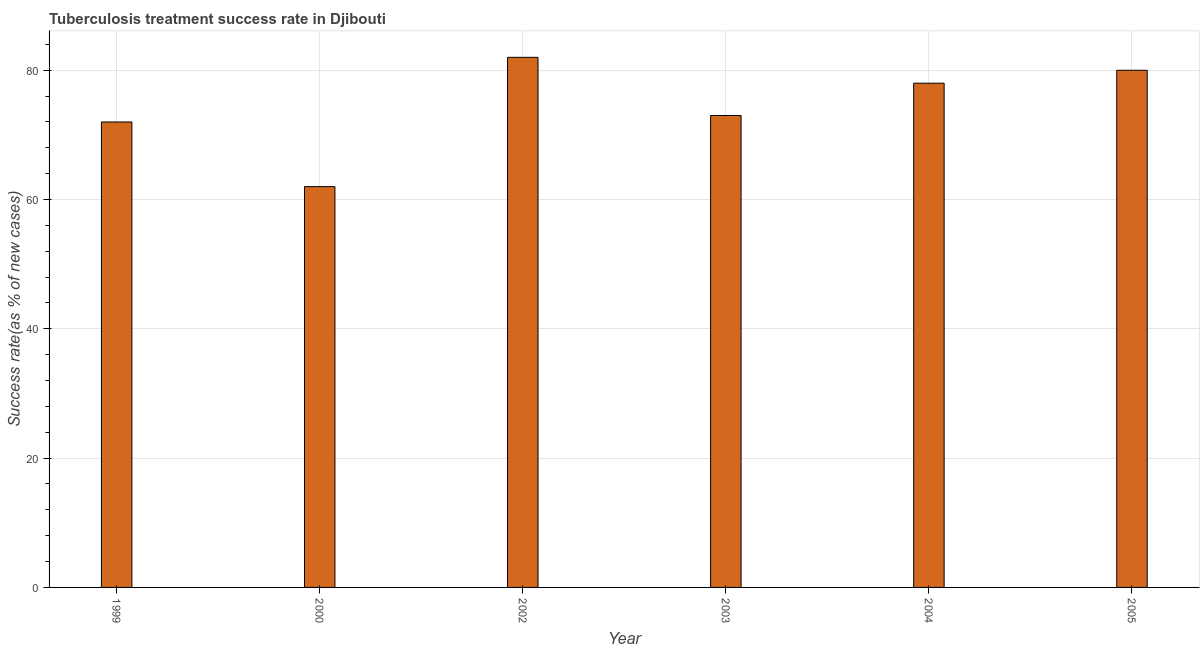Does the graph contain any zero values?
Offer a terse response. No. Does the graph contain grids?
Ensure brevity in your answer.  Yes. What is the title of the graph?
Your response must be concise. Tuberculosis treatment success rate in Djibouti. What is the label or title of the Y-axis?
Offer a very short reply. Success rate(as % of new cases). Across all years, what is the maximum tuberculosis treatment success rate?
Make the answer very short. 82. Across all years, what is the minimum tuberculosis treatment success rate?
Ensure brevity in your answer.  62. What is the sum of the tuberculosis treatment success rate?
Offer a terse response. 447. What is the difference between the tuberculosis treatment success rate in 1999 and 2005?
Your answer should be very brief. -8. What is the average tuberculosis treatment success rate per year?
Make the answer very short. 74. What is the median tuberculosis treatment success rate?
Make the answer very short. 75.5. Do a majority of the years between 2002 and 2000 (inclusive) have tuberculosis treatment success rate greater than 8 %?
Provide a short and direct response. No. Is the tuberculosis treatment success rate in 2000 less than that in 2003?
Give a very brief answer. Yes. What is the difference between the highest and the second highest tuberculosis treatment success rate?
Ensure brevity in your answer.  2. In how many years, is the tuberculosis treatment success rate greater than the average tuberculosis treatment success rate taken over all years?
Ensure brevity in your answer.  3. What is the difference between the Success rate(as % of new cases) in 1999 and 2000?
Make the answer very short. 10. What is the difference between the Success rate(as % of new cases) in 1999 and 2002?
Make the answer very short. -10. What is the difference between the Success rate(as % of new cases) in 2000 and 2004?
Give a very brief answer. -16. What is the difference between the Success rate(as % of new cases) in 2000 and 2005?
Give a very brief answer. -18. What is the difference between the Success rate(as % of new cases) in 2002 and 2005?
Provide a short and direct response. 2. What is the difference between the Success rate(as % of new cases) in 2003 and 2004?
Your answer should be compact. -5. What is the ratio of the Success rate(as % of new cases) in 1999 to that in 2000?
Your response must be concise. 1.16. What is the ratio of the Success rate(as % of new cases) in 1999 to that in 2002?
Provide a succinct answer. 0.88. What is the ratio of the Success rate(as % of new cases) in 1999 to that in 2004?
Ensure brevity in your answer.  0.92. What is the ratio of the Success rate(as % of new cases) in 2000 to that in 2002?
Offer a terse response. 0.76. What is the ratio of the Success rate(as % of new cases) in 2000 to that in 2003?
Your answer should be very brief. 0.85. What is the ratio of the Success rate(as % of new cases) in 2000 to that in 2004?
Make the answer very short. 0.8. What is the ratio of the Success rate(as % of new cases) in 2000 to that in 2005?
Offer a terse response. 0.78. What is the ratio of the Success rate(as % of new cases) in 2002 to that in 2003?
Keep it short and to the point. 1.12. What is the ratio of the Success rate(as % of new cases) in 2002 to that in 2004?
Ensure brevity in your answer.  1.05. What is the ratio of the Success rate(as % of new cases) in 2003 to that in 2004?
Give a very brief answer. 0.94. What is the ratio of the Success rate(as % of new cases) in 2003 to that in 2005?
Your answer should be compact. 0.91. What is the ratio of the Success rate(as % of new cases) in 2004 to that in 2005?
Your answer should be compact. 0.97. 